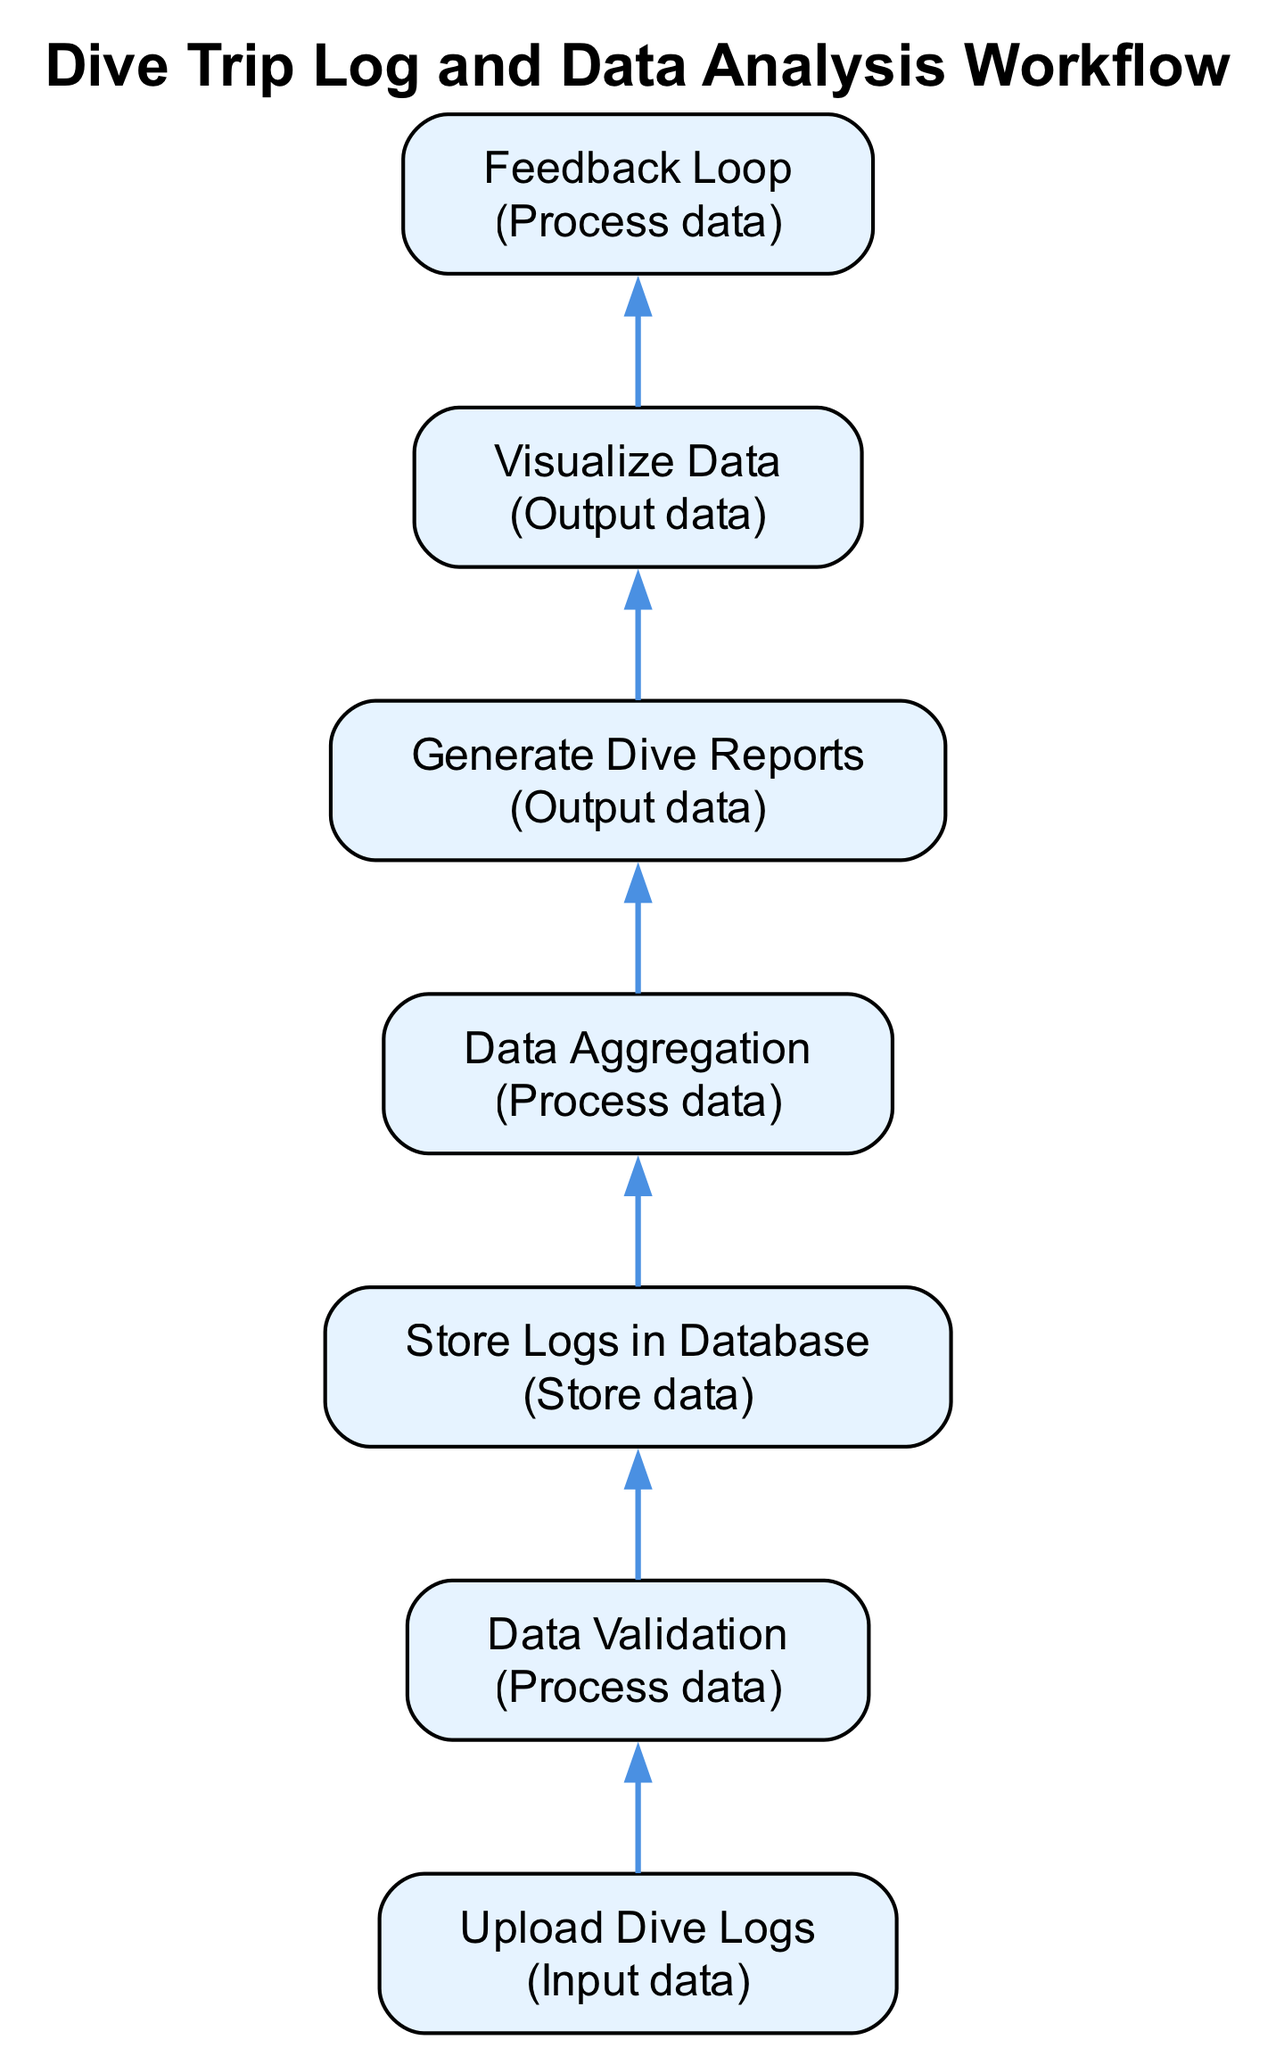What is the first step in the workflow? The first step listed at the bottom of the flowchart is "Upload Dive Logs." This is the initial action that divers take to start the process.
Answer: Upload Dive Logs How many nodes are there in the diagram? By counting each distinct process represented as a node in the flowchart, we see that there are a total of seven nodes.
Answer: Seven What is the action associated with "Visualize Data"? The action connected to "Visualize Data" is "Output data." This describes what that node accomplishes in the workflow.
Answer: Output data Which step comes immediately after "Data Validation"? After "Data Validation," the next step in the flow is "Store Logs in Database." This shows the sequence of actions that follow the validation process.
Answer: Store Logs in Database What do the feedback from divers impact in the workflow? The feedback from divers is incorporated to improve future dive trips, which indicates that it feeds back into the workflow at the "Feedback Loop" stage.
Answer: Future dive trips Which two steps are primarily focused on data processing? The two steps centered on data processing in this workflow are "Data Validation" and "Data Aggregation." These steps involve checking and summarizing data respectively.
Answer: Data Validation and Data Aggregation What is the connection between "Generate Dive Reports" and "Visualize Data"? "Generate Dive Reports" leads directly to "Visualize Data," meaning the reports produced serve as a basis for creating visual representations. This connection illustrates how the result of one step informs the next.
Answer: Generate Dive Reports leads to Visualize Data How many data output steps are present in the diagram? Counting the nodes labeled with "Output data," we see there are two: "Generate Dive Reports" and "Visualize Data." This shows the focus on results being shared in the workflow.
Answer: Two What are the last two steps in the workflow? The last two steps before the workflow concludes are "Visualize Data" followed by "Feedback Loop," indicating the continuous nature of the process where data visualization impacts user input.
Answer: Visualize Data and Feedback Loop 